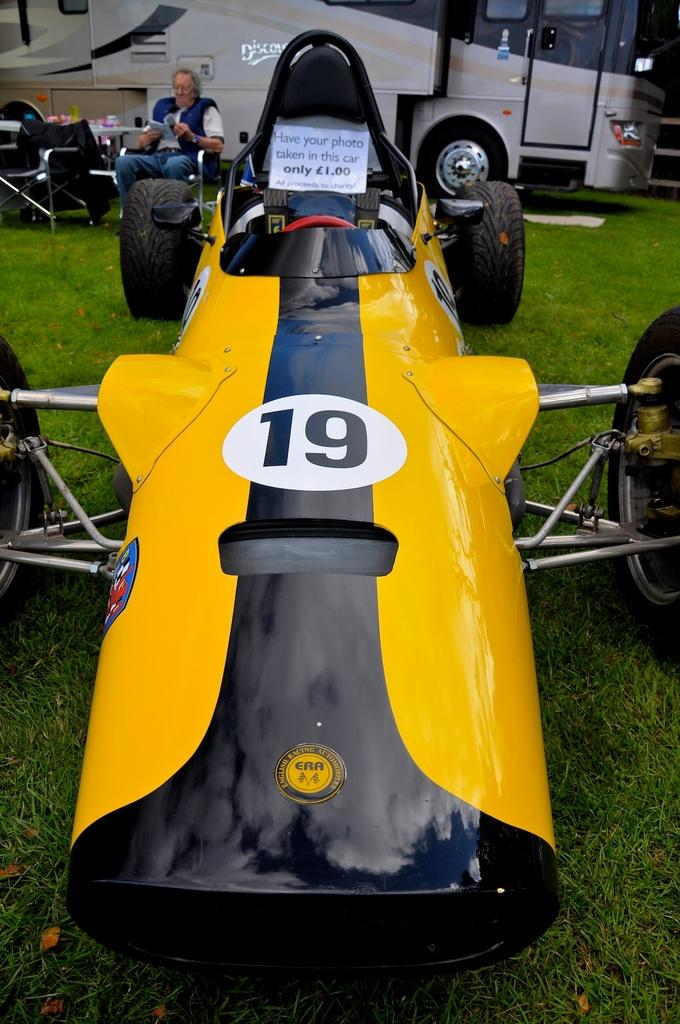What type of vehicle is in the image? There is a yellow vehicle in the image. Can you describe the man's position in the image? There is a man sitting on a chair on the left side of the image. What other mode of transportation can be seen in the image? There is a bus visible at the top of the image. What type of ship can be seen sailing in the background of the image? There is no ship visible in the image; it only features a yellow vehicle, a man sitting on a chair, and a bus. 